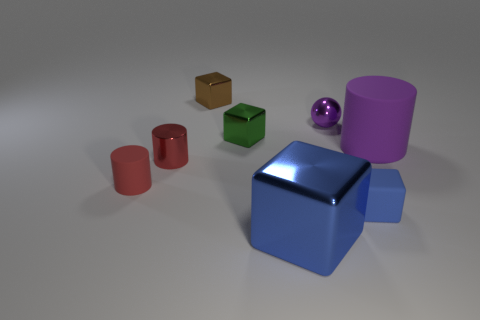Add 1 brown metal objects. How many objects exist? 9 Subtract all spheres. How many objects are left? 7 Add 8 purple matte things. How many purple matte things are left? 9 Add 1 gray shiny cylinders. How many gray shiny cylinders exist? 1 Subtract 0 yellow cylinders. How many objects are left? 8 Subtract all large purple rubber blocks. Subtract all large rubber things. How many objects are left? 7 